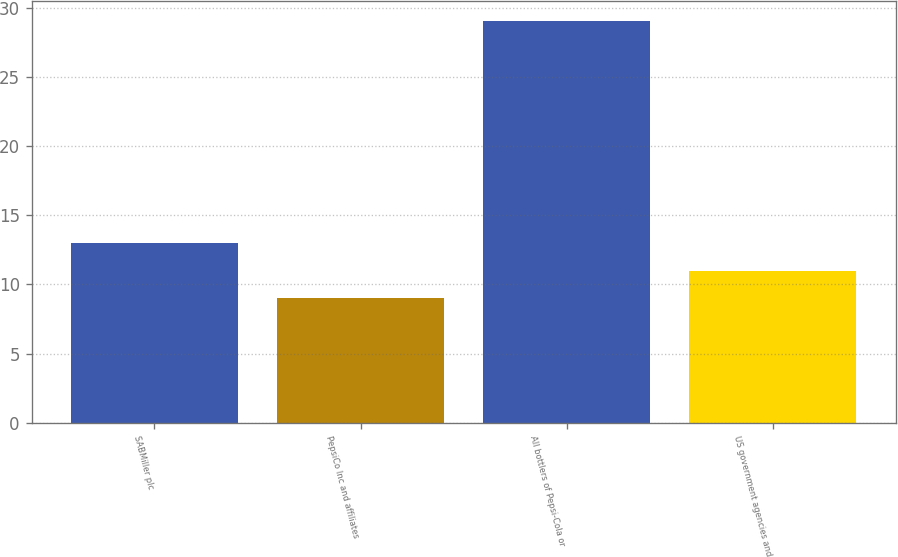Convert chart. <chart><loc_0><loc_0><loc_500><loc_500><bar_chart><fcel>SABMiller plc<fcel>PepsiCo Inc and affiliates<fcel>All bottlers of Pepsi-Cola or<fcel>US government agencies and<nl><fcel>13<fcel>9<fcel>29<fcel>11<nl></chart> 